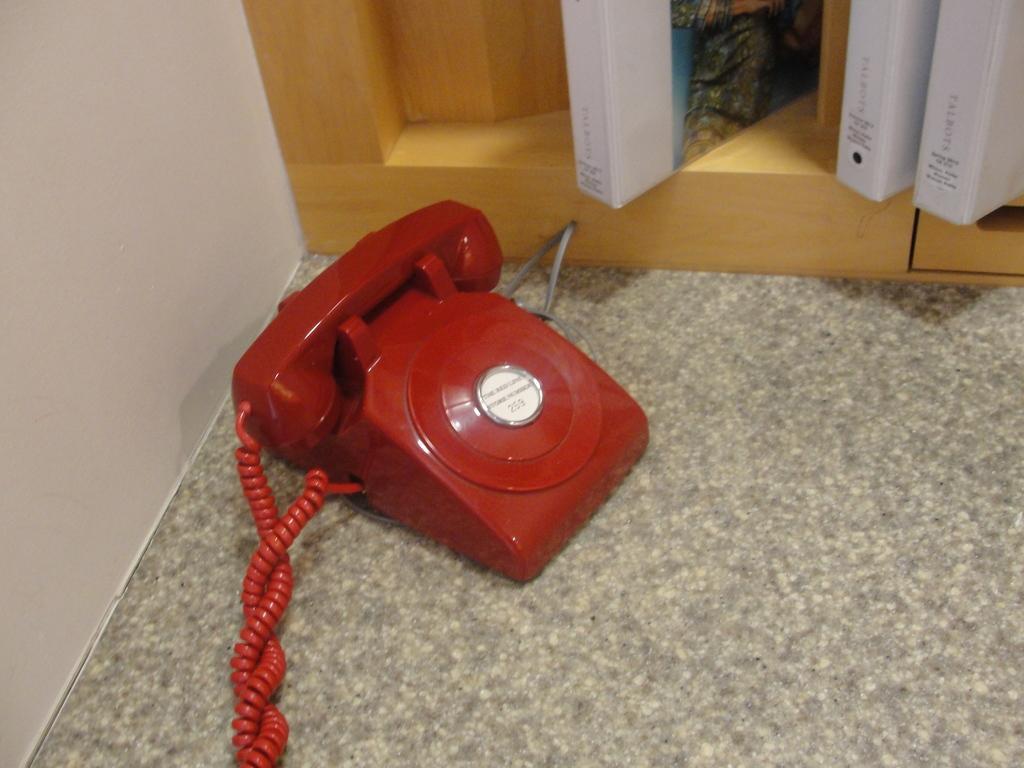In one or two sentences, can you explain what this image depicts? In the center of the image we can see telephone, wires. At the top of the image we can see rack, books. On the left side of the image there is a wall. At the bottom of the image we can see the floor. 